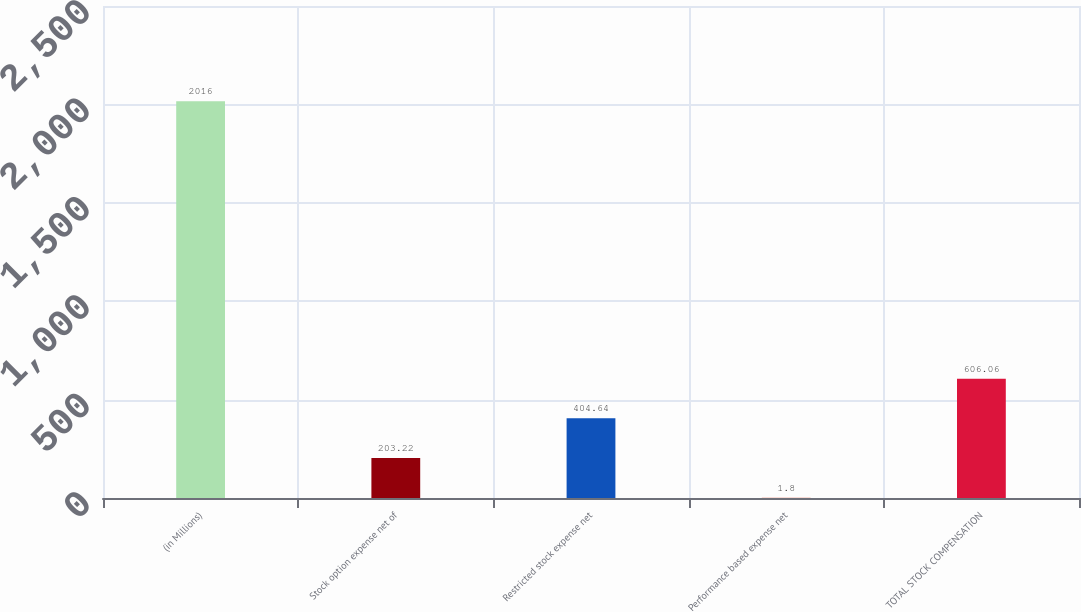Convert chart. <chart><loc_0><loc_0><loc_500><loc_500><bar_chart><fcel>(in Millions)<fcel>Stock option expense net of<fcel>Restricted stock expense net<fcel>Performance based expense net<fcel>TOTAL STOCK COMPENSATION<nl><fcel>2016<fcel>203.22<fcel>404.64<fcel>1.8<fcel>606.06<nl></chart> 